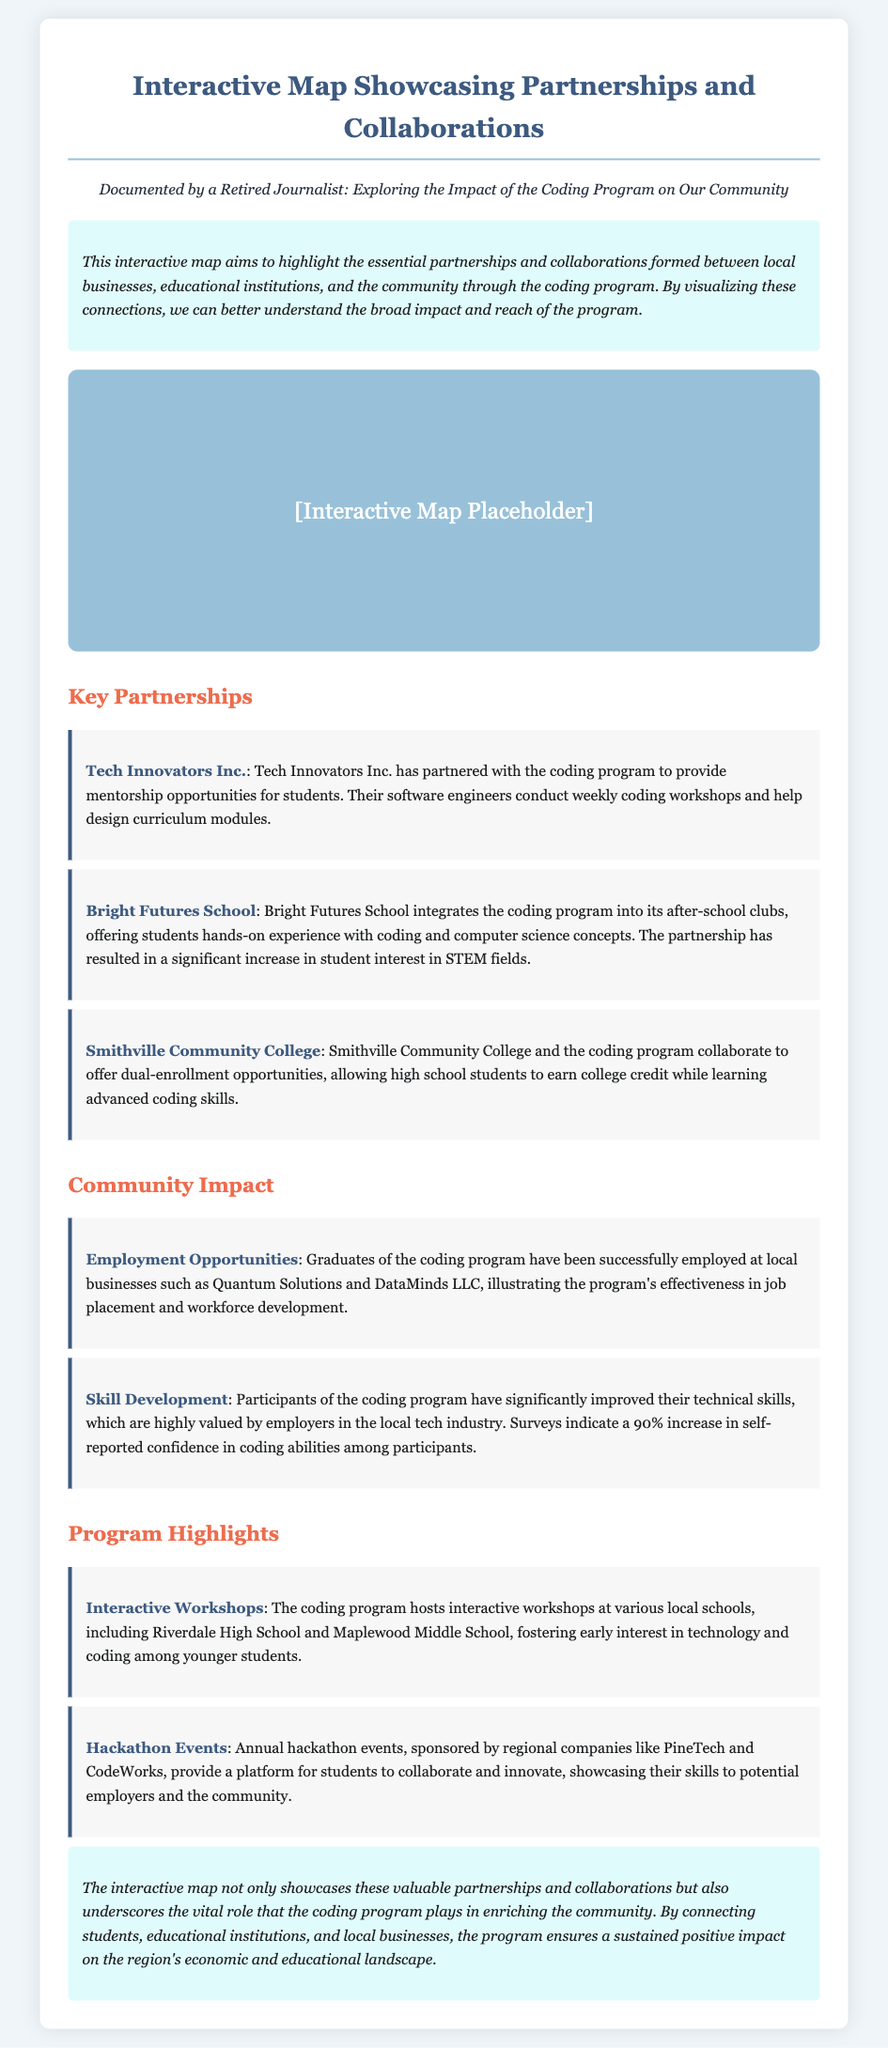What is the title of the document? The title appears at the top of the document within the header section.
Answer: Interactive Map Showcase - Coding Program Partnerships Who is the persona documented in the introduction? The persona is mentioned in a specific section indicating their background and role documented in the introduction.
Answer: A Retired Journalist Which business collaborates to provide mentorship opportunities? The document lists specific businesses and their contributions to the coding program, one of which provides mentorship opportunities.
Answer: Tech Innovators Inc What educational institution integrates the coding program into after-school clubs? The partnerships are outlined in the document, highlighting different institutions and their roles, including this one.
Answer: Bright Futures School What percentage increase in self-reported confidence do participants experience? The document includes statistics about skill development that detail the confidence reported by participants.
Answer: 90% Which companies sponsor annual hackathon events? The document identifies specific companies that support the coding program's hackathon events, highlighting their contributions.
Answer: PineTech and CodeWorks What is one of the outcomes of the partnership with Smithville Community College? The document describes the collaboration outcomes with educational institutions, focusing on specific offerings such as dual-enrollment.
Answer: Dual-enrollment opportunities What type of workshops does the coding program host? The document describes specific workshop types hosted by the coding program, indicating their purpose and setting.
Answer: Interactive Workshops 